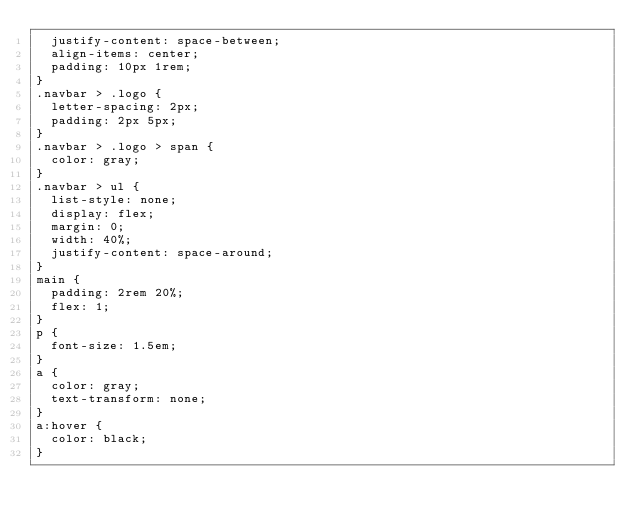Convert code to text. <code><loc_0><loc_0><loc_500><loc_500><_CSS_>  justify-content: space-between;
  align-items: center;
  padding: 10px 1rem;
}
.navbar > .logo {
  letter-spacing: 2px;
  padding: 2px 5px;
}
.navbar > .logo > span {
  color: gray;
}
.navbar > ul {
  list-style: none;
  display: flex;
  margin: 0;
  width: 40%;
  justify-content: space-around;
}
main {
  padding: 2rem 20%;
  flex: 1;
}
p {
  font-size: 1.5em;
}
a {
  color: gray;
  text-transform: none;
}
a:hover {
  color: black;
}</code> 